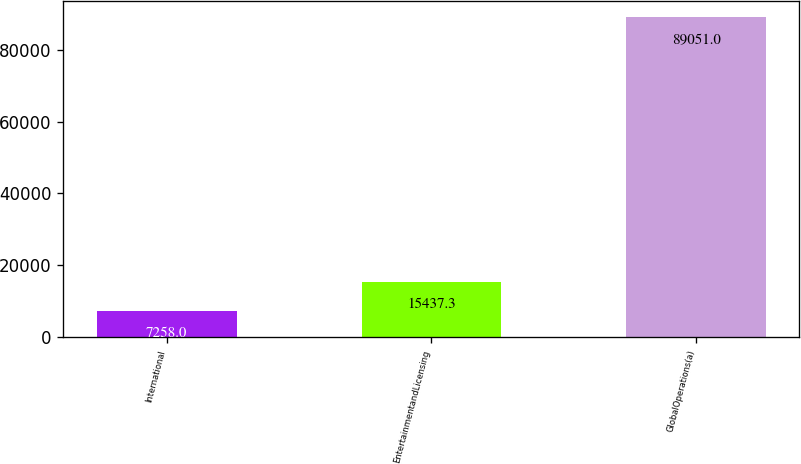<chart> <loc_0><loc_0><loc_500><loc_500><bar_chart><fcel>International<fcel>EntertainmentandLicensing<fcel>GlobalOperations(a)<nl><fcel>7258<fcel>15437.3<fcel>89051<nl></chart> 